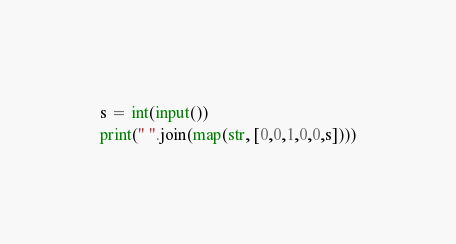Convert code to text. <code><loc_0><loc_0><loc_500><loc_500><_Python_>s = int(input())
print(" ".join(map(str, [0,0,1,0,0,s])))</code> 